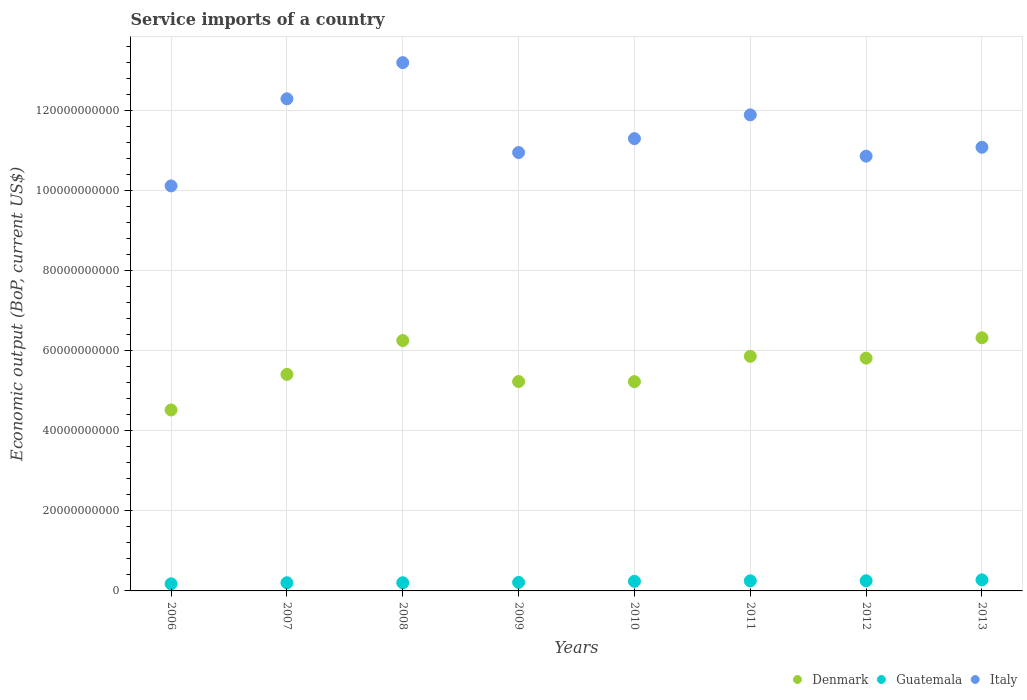How many different coloured dotlines are there?
Give a very brief answer. 3. Is the number of dotlines equal to the number of legend labels?
Make the answer very short. Yes. What is the service imports in Guatemala in 2012?
Provide a succinct answer. 2.54e+09. Across all years, what is the maximum service imports in Denmark?
Make the answer very short. 6.33e+1. Across all years, what is the minimum service imports in Guatemala?
Keep it short and to the point. 1.78e+09. In which year was the service imports in Denmark minimum?
Ensure brevity in your answer.  2006. What is the total service imports in Italy in the graph?
Your answer should be very brief. 9.17e+11. What is the difference between the service imports in Italy in 2009 and that in 2011?
Your answer should be very brief. -9.42e+09. What is the difference between the service imports in Denmark in 2007 and the service imports in Guatemala in 2009?
Ensure brevity in your answer.  5.20e+1. What is the average service imports in Guatemala per year?
Make the answer very short. 2.28e+09. In the year 2011, what is the difference between the service imports in Denmark and service imports in Guatemala?
Keep it short and to the point. 5.61e+1. What is the ratio of the service imports in Italy in 2006 to that in 2011?
Make the answer very short. 0.85. Is the service imports in Guatemala in 2007 less than that in 2013?
Your answer should be compact. Yes. What is the difference between the highest and the second highest service imports in Denmark?
Give a very brief answer. 6.86e+08. What is the difference between the highest and the lowest service imports in Guatemala?
Keep it short and to the point. 9.79e+08. In how many years, is the service imports in Italy greater than the average service imports in Italy taken over all years?
Your response must be concise. 3. Is it the case that in every year, the sum of the service imports in Guatemala and service imports in Italy  is greater than the service imports in Denmark?
Provide a short and direct response. Yes. Does the service imports in Italy monotonically increase over the years?
Give a very brief answer. No. Is the service imports in Denmark strictly greater than the service imports in Italy over the years?
Provide a short and direct response. No. Is the service imports in Denmark strictly less than the service imports in Italy over the years?
Offer a very short reply. Yes. How many years are there in the graph?
Give a very brief answer. 8. Are the values on the major ticks of Y-axis written in scientific E-notation?
Your response must be concise. No. Does the graph contain any zero values?
Your response must be concise. No. Does the graph contain grids?
Provide a succinct answer. Yes. Where does the legend appear in the graph?
Ensure brevity in your answer.  Bottom right. How are the legend labels stacked?
Offer a terse response. Horizontal. What is the title of the graph?
Your response must be concise. Service imports of a country. What is the label or title of the X-axis?
Offer a very short reply. Years. What is the label or title of the Y-axis?
Your answer should be compact. Economic output (BoP, current US$). What is the Economic output (BoP, current US$) in Denmark in 2006?
Keep it short and to the point. 4.52e+1. What is the Economic output (BoP, current US$) of Guatemala in 2006?
Ensure brevity in your answer.  1.78e+09. What is the Economic output (BoP, current US$) of Italy in 2006?
Provide a short and direct response. 1.01e+11. What is the Economic output (BoP, current US$) in Denmark in 2007?
Your response must be concise. 5.41e+1. What is the Economic output (BoP, current US$) of Guatemala in 2007?
Your response must be concise. 2.04e+09. What is the Economic output (BoP, current US$) of Italy in 2007?
Offer a terse response. 1.23e+11. What is the Economic output (BoP, current US$) of Denmark in 2008?
Give a very brief answer. 6.26e+1. What is the Economic output (BoP, current US$) in Guatemala in 2008?
Your answer should be compact. 2.04e+09. What is the Economic output (BoP, current US$) of Italy in 2008?
Your answer should be compact. 1.32e+11. What is the Economic output (BoP, current US$) in Denmark in 2009?
Your answer should be compact. 5.23e+1. What is the Economic output (BoP, current US$) in Guatemala in 2009?
Offer a terse response. 2.13e+09. What is the Economic output (BoP, current US$) in Italy in 2009?
Your response must be concise. 1.10e+11. What is the Economic output (BoP, current US$) in Denmark in 2010?
Provide a succinct answer. 5.23e+1. What is the Economic output (BoP, current US$) in Guatemala in 2010?
Your response must be concise. 2.41e+09. What is the Economic output (BoP, current US$) in Italy in 2010?
Keep it short and to the point. 1.13e+11. What is the Economic output (BoP, current US$) in Denmark in 2011?
Offer a very short reply. 5.86e+1. What is the Economic output (BoP, current US$) in Guatemala in 2011?
Offer a terse response. 2.52e+09. What is the Economic output (BoP, current US$) in Italy in 2011?
Your response must be concise. 1.19e+11. What is the Economic output (BoP, current US$) of Denmark in 2012?
Keep it short and to the point. 5.82e+1. What is the Economic output (BoP, current US$) in Guatemala in 2012?
Offer a terse response. 2.54e+09. What is the Economic output (BoP, current US$) in Italy in 2012?
Give a very brief answer. 1.09e+11. What is the Economic output (BoP, current US$) of Denmark in 2013?
Your response must be concise. 6.33e+1. What is the Economic output (BoP, current US$) in Guatemala in 2013?
Your answer should be very brief. 2.76e+09. What is the Economic output (BoP, current US$) of Italy in 2013?
Give a very brief answer. 1.11e+11. Across all years, what is the maximum Economic output (BoP, current US$) in Denmark?
Ensure brevity in your answer.  6.33e+1. Across all years, what is the maximum Economic output (BoP, current US$) of Guatemala?
Your response must be concise. 2.76e+09. Across all years, what is the maximum Economic output (BoP, current US$) in Italy?
Make the answer very short. 1.32e+11. Across all years, what is the minimum Economic output (BoP, current US$) of Denmark?
Ensure brevity in your answer.  4.52e+1. Across all years, what is the minimum Economic output (BoP, current US$) in Guatemala?
Your response must be concise. 1.78e+09. Across all years, what is the minimum Economic output (BoP, current US$) in Italy?
Give a very brief answer. 1.01e+11. What is the total Economic output (BoP, current US$) in Denmark in the graph?
Keep it short and to the point. 4.47e+11. What is the total Economic output (BoP, current US$) of Guatemala in the graph?
Offer a very short reply. 1.82e+1. What is the total Economic output (BoP, current US$) in Italy in the graph?
Your response must be concise. 9.17e+11. What is the difference between the Economic output (BoP, current US$) of Denmark in 2006 and that in 2007?
Your answer should be very brief. -8.89e+09. What is the difference between the Economic output (BoP, current US$) of Guatemala in 2006 and that in 2007?
Keep it short and to the point. -2.63e+08. What is the difference between the Economic output (BoP, current US$) of Italy in 2006 and that in 2007?
Your answer should be compact. -2.18e+1. What is the difference between the Economic output (BoP, current US$) in Denmark in 2006 and that in 2008?
Offer a terse response. -1.74e+1. What is the difference between the Economic output (BoP, current US$) of Guatemala in 2006 and that in 2008?
Keep it short and to the point. -2.65e+08. What is the difference between the Economic output (BoP, current US$) of Italy in 2006 and that in 2008?
Provide a succinct answer. -3.08e+1. What is the difference between the Economic output (BoP, current US$) of Denmark in 2006 and that in 2009?
Give a very brief answer. -7.11e+09. What is the difference between the Economic output (BoP, current US$) of Guatemala in 2006 and that in 2009?
Your response must be concise. -3.53e+08. What is the difference between the Economic output (BoP, current US$) of Italy in 2006 and that in 2009?
Your response must be concise. -8.34e+09. What is the difference between the Economic output (BoP, current US$) in Denmark in 2006 and that in 2010?
Give a very brief answer. -7.08e+09. What is the difference between the Economic output (BoP, current US$) in Guatemala in 2006 and that in 2010?
Provide a short and direct response. -6.29e+08. What is the difference between the Economic output (BoP, current US$) of Italy in 2006 and that in 2010?
Your answer should be compact. -1.18e+1. What is the difference between the Economic output (BoP, current US$) in Denmark in 2006 and that in 2011?
Provide a succinct answer. -1.34e+1. What is the difference between the Economic output (BoP, current US$) in Guatemala in 2006 and that in 2011?
Provide a short and direct response. -7.38e+08. What is the difference between the Economic output (BoP, current US$) in Italy in 2006 and that in 2011?
Your answer should be compact. -1.78e+1. What is the difference between the Economic output (BoP, current US$) of Denmark in 2006 and that in 2012?
Ensure brevity in your answer.  -1.29e+1. What is the difference between the Economic output (BoP, current US$) of Guatemala in 2006 and that in 2012?
Offer a very short reply. -7.61e+08. What is the difference between the Economic output (BoP, current US$) in Italy in 2006 and that in 2012?
Your response must be concise. -7.44e+09. What is the difference between the Economic output (BoP, current US$) of Denmark in 2006 and that in 2013?
Offer a very short reply. -1.80e+1. What is the difference between the Economic output (BoP, current US$) of Guatemala in 2006 and that in 2013?
Provide a succinct answer. -9.79e+08. What is the difference between the Economic output (BoP, current US$) in Italy in 2006 and that in 2013?
Ensure brevity in your answer.  -9.66e+09. What is the difference between the Economic output (BoP, current US$) in Denmark in 2007 and that in 2008?
Give a very brief answer. -8.46e+09. What is the difference between the Economic output (BoP, current US$) of Guatemala in 2007 and that in 2008?
Keep it short and to the point. -2.11e+06. What is the difference between the Economic output (BoP, current US$) in Italy in 2007 and that in 2008?
Your answer should be compact. -9.04e+09. What is the difference between the Economic output (BoP, current US$) in Denmark in 2007 and that in 2009?
Your response must be concise. 1.78e+09. What is the difference between the Economic output (BoP, current US$) of Guatemala in 2007 and that in 2009?
Offer a very short reply. -9.03e+07. What is the difference between the Economic output (BoP, current US$) in Italy in 2007 and that in 2009?
Provide a short and direct response. 1.34e+1. What is the difference between the Economic output (BoP, current US$) in Denmark in 2007 and that in 2010?
Your answer should be compact. 1.81e+09. What is the difference between the Economic output (BoP, current US$) in Guatemala in 2007 and that in 2010?
Offer a very short reply. -3.66e+08. What is the difference between the Economic output (BoP, current US$) in Italy in 2007 and that in 2010?
Provide a short and direct response. 9.95e+09. What is the difference between the Economic output (BoP, current US$) in Denmark in 2007 and that in 2011?
Provide a succinct answer. -4.52e+09. What is the difference between the Economic output (BoP, current US$) of Guatemala in 2007 and that in 2011?
Your response must be concise. -4.76e+08. What is the difference between the Economic output (BoP, current US$) of Italy in 2007 and that in 2011?
Give a very brief answer. 4.01e+09. What is the difference between the Economic output (BoP, current US$) in Denmark in 2007 and that in 2012?
Offer a very short reply. -4.06e+09. What is the difference between the Economic output (BoP, current US$) of Guatemala in 2007 and that in 2012?
Ensure brevity in your answer.  -4.98e+08. What is the difference between the Economic output (BoP, current US$) in Italy in 2007 and that in 2012?
Provide a succinct answer. 1.43e+1. What is the difference between the Economic output (BoP, current US$) of Denmark in 2007 and that in 2013?
Offer a terse response. -9.15e+09. What is the difference between the Economic output (BoP, current US$) in Guatemala in 2007 and that in 2013?
Provide a succinct answer. -7.16e+08. What is the difference between the Economic output (BoP, current US$) of Italy in 2007 and that in 2013?
Your answer should be very brief. 1.21e+1. What is the difference between the Economic output (BoP, current US$) in Denmark in 2008 and that in 2009?
Ensure brevity in your answer.  1.02e+1. What is the difference between the Economic output (BoP, current US$) of Guatemala in 2008 and that in 2009?
Your response must be concise. -8.82e+07. What is the difference between the Economic output (BoP, current US$) in Italy in 2008 and that in 2009?
Your answer should be compact. 2.25e+1. What is the difference between the Economic output (BoP, current US$) of Denmark in 2008 and that in 2010?
Ensure brevity in your answer.  1.03e+1. What is the difference between the Economic output (BoP, current US$) of Guatemala in 2008 and that in 2010?
Keep it short and to the point. -3.64e+08. What is the difference between the Economic output (BoP, current US$) of Italy in 2008 and that in 2010?
Your answer should be very brief. 1.90e+1. What is the difference between the Economic output (BoP, current US$) of Denmark in 2008 and that in 2011?
Ensure brevity in your answer.  3.94e+09. What is the difference between the Economic output (BoP, current US$) of Guatemala in 2008 and that in 2011?
Ensure brevity in your answer.  -4.74e+08. What is the difference between the Economic output (BoP, current US$) of Italy in 2008 and that in 2011?
Your answer should be compact. 1.31e+1. What is the difference between the Economic output (BoP, current US$) of Denmark in 2008 and that in 2012?
Provide a short and direct response. 4.40e+09. What is the difference between the Economic output (BoP, current US$) of Guatemala in 2008 and that in 2012?
Ensure brevity in your answer.  -4.96e+08. What is the difference between the Economic output (BoP, current US$) in Italy in 2008 and that in 2012?
Make the answer very short. 2.34e+1. What is the difference between the Economic output (BoP, current US$) of Denmark in 2008 and that in 2013?
Offer a very short reply. -6.86e+08. What is the difference between the Economic output (BoP, current US$) in Guatemala in 2008 and that in 2013?
Make the answer very short. -7.14e+08. What is the difference between the Economic output (BoP, current US$) in Italy in 2008 and that in 2013?
Offer a terse response. 2.12e+1. What is the difference between the Economic output (BoP, current US$) in Denmark in 2009 and that in 2010?
Offer a very short reply. 2.79e+07. What is the difference between the Economic output (BoP, current US$) of Guatemala in 2009 and that in 2010?
Give a very brief answer. -2.76e+08. What is the difference between the Economic output (BoP, current US$) in Italy in 2009 and that in 2010?
Ensure brevity in your answer.  -3.48e+09. What is the difference between the Economic output (BoP, current US$) of Denmark in 2009 and that in 2011?
Provide a short and direct response. -6.30e+09. What is the difference between the Economic output (BoP, current US$) in Guatemala in 2009 and that in 2011?
Your answer should be compact. -3.85e+08. What is the difference between the Economic output (BoP, current US$) in Italy in 2009 and that in 2011?
Provide a short and direct response. -9.42e+09. What is the difference between the Economic output (BoP, current US$) in Denmark in 2009 and that in 2012?
Your response must be concise. -5.84e+09. What is the difference between the Economic output (BoP, current US$) of Guatemala in 2009 and that in 2012?
Make the answer very short. -4.08e+08. What is the difference between the Economic output (BoP, current US$) of Italy in 2009 and that in 2012?
Give a very brief answer. 9.00e+08. What is the difference between the Economic output (BoP, current US$) of Denmark in 2009 and that in 2013?
Offer a terse response. -1.09e+1. What is the difference between the Economic output (BoP, current US$) of Guatemala in 2009 and that in 2013?
Provide a short and direct response. -6.25e+08. What is the difference between the Economic output (BoP, current US$) of Italy in 2009 and that in 2013?
Keep it short and to the point. -1.32e+09. What is the difference between the Economic output (BoP, current US$) of Denmark in 2010 and that in 2011?
Your answer should be very brief. -6.33e+09. What is the difference between the Economic output (BoP, current US$) of Guatemala in 2010 and that in 2011?
Your answer should be very brief. -1.10e+08. What is the difference between the Economic output (BoP, current US$) of Italy in 2010 and that in 2011?
Make the answer very short. -5.94e+09. What is the difference between the Economic output (BoP, current US$) in Denmark in 2010 and that in 2012?
Give a very brief answer. -5.87e+09. What is the difference between the Economic output (BoP, current US$) of Guatemala in 2010 and that in 2012?
Your response must be concise. -1.32e+08. What is the difference between the Economic output (BoP, current US$) in Italy in 2010 and that in 2012?
Keep it short and to the point. 4.38e+09. What is the difference between the Economic output (BoP, current US$) of Denmark in 2010 and that in 2013?
Offer a terse response. -1.10e+1. What is the difference between the Economic output (BoP, current US$) in Guatemala in 2010 and that in 2013?
Give a very brief answer. -3.50e+08. What is the difference between the Economic output (BoP, current US$) of Italy in 2010 and that in 2013?
Your answer should be very brief. 2.16e+09. What is the difference between the Economic output (BoP, current US$) in Denmark in 2011 and that in 2012?
Offer a terse response. 4.63e+08. What is the difference between the Economic output (BoP, current US$) of Guatemala in 2011 and that in 2012?
Your answer should be very brief. -2.26e+07. What is the difference between the Economic output (BoP, current US$) in Italy in 2011 and that in 2012?
Provide a succinct answer. 1.03e+1. What is the difference between the Economic output (BoP, current US$) of Denmark in 2011 and that in 2013?
Give a very brief answer. -4.63e+09. What is the difference between the Economic output (BoP, current US$) of Guatemala in 2011 and that in 2013?
Your answer should be very brief. -2.40e+08. What is the difference between the Economic output (BoP, current US$) in Italy in 2011 and that in 2013?
Your response must be concise. 8.10e+09. What is the difference between the Economic output (BoP, current US$) in Denmark in 2012 and that in 2013?
Your response must be concise. -5.09e+09. What is the difference between the Economic output (BoP, current US$) in Guatemala in 2012 and that in 2013?
Your response must be concise. -2.18e+08. What is the difference between the Economic output (BoP, current US$) of Italy in 2012 and that in 2013?
Ensure brevity in your answer.  -2.22e+09. What is the difference between the Economic output (BoP, current US$) of Denmark in 2006 and the Economic output (BoP, current US$) of Guatemala in 2007?
Provide a succinct answer. 4.32e+1. What is the difference between the Economic output (BoP, current US$) in Denmark in 2006 and the Economic output (BoP, current US$) in Italy in 2007?
Make the answer very short. -7.78e+1. What is the difference between the Economic output (BoP, current US$) of Guatemala in 2006 and the Economic output (BoP, current US$) of Italy in 2007?
Provide a short and direct response. -1.21e+11. What is the difference between the Economic output (BoP, current US$) of Denmark in 2006 and the Economic output (BoP, current US$) of Guatemala in 2008?
Provide a succinct answer. 4.32e+1. What is the difference between the Economic output (BoP, current US$) in Denmark in 2006 and the Economic output (BoP, current US$) in Italy in 2008?
Provide a short and direct response. -8.68e+1. What is the difference between the Economic output (BoP, current US$) in Guatemala in 2006 and the Economic output (BoP, current US$) in Italy in 2008?
Provide a short and direct response. -1.30e+11. What is the difference between the Economic output (BoP, current US$) of Denmark in 2006 and the Economic output (BoP, current US$) of Guatemala in 2009?
Provide a short and direct response. 4.31e+1. What is the difference between the Economic output (BoP, current US$) in Denmark in 2006 and the Economic output (BoP, current US$) in Italy in 2009?
Provide a succinct answer. -6.43e+1. What is the difference between the Economic output (BoP, current US$) in Guatemala in 2006 and the Economic output (BoP, current US$) in Italy in 2009?
Give a very brief answer. -1.08e+11. What is the difference between the Economic output (BoP, current US$) of Denmark in 2006 and the Economic output (BoP, current US$) of Guatemala in 2010?
Provide a succinct answer. 4.28e+1. What is the difference between the Economic output (BoP, current US$) in Denmark in 2006 and the Economic output (BoP, current US$) in Italy in 2010?
Provide a succinct answer. -6.78e+1. What is the difference between the Economic output (BoP, current US$) of Guatemala in 2006 and the Economic output (BoP, current US$) of Italy in 2010?
Your answer should be compact. -1.11e+11. What is the difference between the Economic output (BoP, current US$) in Denmark in 2006 and the Economic output (BoP, current US$) in Guatemala in 2011?
Give a very brief answer. 4.27e+1. What is the difference between the Economic output (BoP, current US$) of Denmark in 2006 and the Economic output (BoP, current US$) of Italy in 2011?
Keep it short and to the point. -7.38e+1. What is the difference between the Economic output (BoP, current US$) in Guatemala in 2006 and the Economic output (BoP, current US$) in Italy in 2011?
Your answer should be compact. -1.17e+11. What is the difference between the Economic output (BoP, current US$) of Denmark in 2006 and the Economic output (BoP, current US$) of Guatemala in 2012?
Your answer should be very brief. 4.27e+1. What is the difference between the Economic output (BoP, current US$) in Denmark in 2006 and the Economic output (BoP, current US$) in Italy in 2012?
Offer a terse response. -6.34e+1. What is the difference between the Economic output (BoP, current US$) of Guatemala in 2006 and the Economic output (BoP, current US$) of Italy in 2012?
Your answer should be compact. -1.07e+11. What is the difference between the Economic output (BoP, current US$) in Denmark in 2006 and the Economic output (BoP, current US$) in Guatemala in 2013?
Keep it short and to the point. 4.25e+1. What is the difference between the Economic output (BoP, current US$) of Denmark in 2006 and the Economic output (BoP, current US$) of Italy in 2013?
Your answer should be compact. -6.57e+1. What is the difference between the Economic output (BoP, current US$) of Guatemala in 2006 and the Economic output (BoP, current US$) of Italy in 2013?
Your response must be concise. -1.09e+11. What is the difference between the Economic output (BoP, current US$) of Denmark in 2007 and the Economic output (BoP, current US$) of Guatemala in 2008?
Give a very brief answer. 5.21e+1. What is the difference between the Economic output (BoP, current US$) in Denmark in 2007 and the Economic output (BoP, current US$) in Italy in 2008?
Offer a terse response. -7.79e+1. What is the difference between the Economic output (BoP, current US$) of Guatemala in 2007 and the Economic output (BoP, current US$) of Italy in 2008?
Ensure brevity in your answer.  -1.30e+11. What is the difference between the Economic output (BoP, current US$) of Denmark in 2007 and the Economic output (BoP, current US$) of Guatemala in 2009?
Your response must be concise. 5.20e+1. What is the difference between the Economic output (BoP, current US$) of Denmark in 2007 and the Economic output (BoP, current US$) of Italy in 2009?
Keep it short and to the point. -5.55e+1. What is the difference between the Economic output (BoP, current US$) of Guatemala in 2007 and the Economic output (BoP, current US$) of Italy in 2009?
Make the answer very short. -1.08e+11. What is the difference between the Economic output (BoP, current US$) of Denmark in 2007 and the Economic output (BoP, current US$) of Guatemala in 2010?
Ensure brevity in your answer.  5.17e+1. What is the difference between the Economic output (BoP, current US$) of Denmark in 2007 and the Economic output (BoP, current US$) of Italy in 2010?
Ensure brevity in your answer.  -5.89e+1. What is the difference between the Economic output (BoP, current US$) of Guatemala in 2007 and the Economic output (BoP, current US$) of Italy in 2010?
Your answer should be very brief. -1.11e+11. What is the difference between the Economic output (BoP, current US$) of Denmark in 2007 and the Economic output (BoP, current US$) of Guatemala in 2011?
Keep it short and to the point. 5.16e+1. What is the difference between the Economic output (BoP, current US$) in Denmark in 2007 and the Economic output (BoP, current US$) in Italy in 2011?
Keep it short and to the point. -6.49e+1. What is the difference between the Economic output (BoP, current US$) of Guatemala in 2007 and the Economic output (BoP, current US$) of Italy in 2011?
Ensure brevity in your answer.  -1.17e+11. What is the difference between the Economic output (BoP, current US$) in Denmark in 2007 and the Economic output (BoP, current US$) in Guatemala in 2012?
Offer a very short reply. 5.16e+1. What is the difference between the Economic output (BoP, current US$) of Denmark in 2007 and the Economic output (BoP, current US$) of Italy in 2012?
Make the answer very short. -5.46e+1. What is the difference between the Economic output (BoP, current US$) of Guatemala in 2007 and the Economic output (BoP, current US$) of Italy in 2012?
Keep it short and to the point. -1.07e+11. What is the difference between the Economic output (BoP, current US$) in Denmark in 2007 and the Economic output (BoP, current US$) in Guatemala in 2013?
Make the answer very short. 5.14e+1. What is the difference between the Economic output (BoP, current US$) in Denmark in 2007 and the Economic output (BoP, current US$) in Italy in 2013?
Offer a terse response. -5.68e+1. What is the difference between the Economic output (BoP, current US$) in Guatemala in 2007 and the Economic output (BoP, current US$) in Italy in 2013?
Provide a short and direct response. -1.09e+11. What is the difference between the Economic output (BoP, current US$) in Denmark in 2008 and the Economic output (BoP, current US$) in Guatemala in 2009?
Your answer should be very brief. 6.05e+1. What is the difference between the Economic output (BoP, current US$) in Denmark in 2008 and the Economic output (BoP, current US$) in Italy in 2009?
Give a very brief answer. -4.70e+1. What is the difference between the Economic output (BoP, current US$) in Guatemala in 2008 and the Economic output (BoP, current US$) in Italy in 2009?
Keep it short and to the point. -1.08e+11. What is the difference between the Economic output (BoP, current US$) in Denmark in 2008 and the Economic output (BoP, current US$) in Guatemala in 2010?
Ensure brevity in your answer.  6.02e+1. What is the difference between the Economic output (BoP, current US$) in Denmark in 2008 and the Economic output (BoP, current US$) in Italy in 2010?
Your response must be concise. -5.05e+1. What is the difference between the Economic output (BoP, current US$) in Guatemala in 2008 and the Economic output (BoP, current US$) in Italy in 2010?
Offer a terse response. -1.11e+11. What is the difference between the Economic output (BoP, current US$) in Denmark in 2008 and the Economic output (BoP, current US$) in Guatemala in 2011?
Give a very brief answer. 6.01e+1. What is the difference between the Economic output (BoP, current US$) in Denmark in 2008 and the Economic output (BoP, current US$) in Italy in 2011?
Provide a succinct answer. -5.64e+1. What is the difference between the Economic output (BoP, current US$) in Guatemala in 2008 and the Economic output (BoP, current US$) in Italy in 2011?
Give a very brief answer. -1.17e+11. What is the difference between the Economic output (BoP, current US$) of Denmark in 2008 and the Economic output (BoP, current US$) of Guatemala in 2012?
Keep it short and to the point. 6.00e+1. What is the difference between the Economic output (BoP, current US$) in Denmark in 2008 and the Economic output (BoP, current US$) in Italy in 2012?
Your answer should be compact. -4.61e+1. What is the difference between the Economic output (BoP, current US$) in Guatemala in 2008 and the Economic output (BoP, current US$) in Italy in 2012?
Offer a terse response. -1.07e+11. What is the difference between the Economic output (BoP, current US$) of Denmark in 2008 and the Economic output (BoP, current US$) of Guatemala in 2013?
Your response must be concise. 5.98e+1. What is the difference between the Economic output (BoP, current US$) in Denmark in 2008 and the Economic output (BoP, current US$) in Italy in 2013?
Give a very brief answer. -4.83e+1. What is the difference between the Economic output (BoP, current US$) of Guatemala in 2008 and the Economic output (BoP, current US$) of Italy in 2013?
Provide a succinct answer. -1.09e+11. What is the difference between the Economic output (BoP, current US$) in Denmark in 2009 and the Economic output (BoP, current US$) in Guatemala in 2010?
Offer a very short reply. 4.99e+1. What is the difference between the Economic output (BoP, current US$) of Denmark in 2009 and the Economic output (BoP, current US$) of Italy in 2010?
Provide a short and direct response. -6.07e+1. What is the difference between the Economic output (BoP, current US$) in Guatemala in 2009 and the Economic output (BoP, current US$) in Italy in 2010?
Offer a terse response. -1.11e+11. What is the difference between the Economic output (BoP, current US$) of Denmark in 2009 and the Economic output (BoP, current US$) of Guatemala in 2011?
Give a very brief answer. 4.98e+1. What is the difference between the Economic output (BoP, current US$) in Denmark in 2009 and the Economic output (BoP, current US$) in Italy in 2011?
Provide a succinct answer. -6.67e+1. What is the difference between the Economic output (BoP, current US$) in Guatemala in 2009 and the Economic output (BoP, current US$) in Italy in 2011?
Your response must be concise. -1.17e+11. What is the difference between the Economic output (BoP, current US$) in Denmark in 2009 and the Economic output (BoP, current US$) in Guatemala in 2012?
Provide a short and direct response. 4.98e+1. What is the difference between the Economic output (BoP, current US$) in Denmark in 2009 and the Economic output (BoP, current US$) in Italy in 2012?
Ensure brevity in your answer.  -5.63e+1. What is the difference between the Economic output (BoP, current US$) in Guatemala in 2009 and the Economic output (BoP, current US$) in Italy in 2012?
Your response must be concise. -1.07e+11. What is the difference between the Economic output (BoP, current US$) of Denmark in 2009 and the Economic output (BoP, current US$) of Guatemala in 2013?
Keep it short and to the point. 4.96e+1. What is the difference between the Economic output (BoP, current US$) in Denmark in 2009 and the Economic output (BoP, current US$) in Italy in 2013?
Ensure brevity in your answer.  -5.86e+1. What is the difference between the Economic output (BoP, current US$) in Guatemala in 2009 and the Economic output (BoP, current US$) in Italy in 2013?
Offer a terse response. -1.09e+11. What is the difference between the Economic output (BoP, current US$) in Denmark in 2010 and the Economic output (BoP, current US$) in Guatemala in 2011?
Make the answer very short. 4.98e+1. What is the difference between the Economic output (BoP, current US$) of Denmark in 2010 and the Economic output (BoP, current US$) of Italy in 2011?
Provide a short and direct response. -6.67e+1. What is the difference between the Economic output (BoP, current US$) of Guatemala in 2010 and the Economic output (BoP, current US$) of Italy in 2011?
Your answer should be very brief. -1.17e+11. What is the difference between the Economic output (BoP, current US$) of Denmark in 2010 and the Economic output (BoP, current US$) of Guatemala in 2012?
Make the answer very short. 4.98e+1. What is the difference between the Economic output (BoP, current US$) in Denmark in 2010 and the Economic output (BoP, current US$) in Italy in 2012?
Offer a terse response. -5.64e+1. What is the difference between the Economic output (BoP, current US$) of Guatemala in 2010 and the Economic output (BoP, current US$) of Italy in 2012?
Keep it short and to the point. -1.06e+11. What is the difference between the Economic output (BoP, current US$) of Denmark in 2010 and the Economic output (BoP, current US$) of Guatemala in 2013?
Ensure brevity in your answer.  4.96e+1. What is the difference between the Economic output (BoP, current US$) in Denmark in 2010 and the Economic output (BoP, current US$) in Italy in 2013?
Give a very brief answer. -5.86e+1. What is the difference between the Economic output (BoP, current US$) of Guatemala in 2010 and the Economic output (BoP, current US$) of Italy in 2013?
Offer a terse response. -1.08e+11. What is the difference between the Economic output (BoP, current US$) in Denmark in 2011 and the Economic output (BoP, current US$) in Guatemala in 2012?
Your answer should be very brief. 5.61e+1. What is the difference between the Economic output (BoP, current US$) in Denmark in 2011 and the Economic output (BoP, current US$) in Italy in 2012?
Provide a short and direct response. -5.00e+1. What is the difference between the Economic output (BoP, current US$) of Guatemala in 2011 and the Economic output (BoP, current US$) of Italy in 2012?
Provide a short and direct response. -1.06e+11. What is the difference between the Economic output (BoP, current US$) of Denmark in 2011 and the Economic output (BoP, current US$) of Guatemala in 2013?
Your answer should be very brief. 5.59e+1. What is the difference between the Economic output (BoP, current US$) in Denmark in 2011 and the Economic output (BoP, current US$) in Italy in 2013?
Give a very brief answer. -5.22e+1. What is the difference between the Economic output (BoP, current US$) in Guatemala in 2011 and the Economic output (BoP, current US$) in Italy in 2013?
Your response must be concise. -1.08e+11. What is the difference between the Economic output (BoP, current US$) of Denmark in 2012 and the Economic output (BoP, current US$) of Guatemala in 2013?
Offer a very short reply. 5.54e+1. What is the difference between the Economic output (BoP, current US$) of Denmark in 2012 and the Economic output (BoP, current US$) of Italy in 2013?
Provide a succinct answer. -5.27e+1. What is the difference between the Economic output (BoP, current US$) of Guatemala in 2012 and the Economic output (BoP, current US$) of Italy in 2013?
Provide a short and direct response. -1.08e+11. What is the average Economic output (BoP, current US$) of Denmark per year?
Make the answer very short. 5.58e+1. What is the average Economic output (BoP, current US$) in Guatemala per year?
Offer a terse response. 2.28e+09. What is the average Economic output (BoP, current US$) of Italy per year?
Provide a succinct answer. 1.15e+11. In the year 2006, what is the difference between the Economic output (BoP, current US$) in Denmark and Economic output (BoP, current US$) in Guatemala?
Your answer should be compact. 4.35e+1. In the year 2006, what is the difference between the Economic output (BoP, current US$) of Denmark and Economic output (BoP, current US$) of Italy?
Make the answer very short. -5.60e+1. In the year 2006, what is the difference between the Economic output (BoP, current US$) in Guatemala and Economic output (BoP, current US$) in Italy?
Offer a terse response. -9.95e+1. In the year 2007, what is the difference between the Economic output (BoP, current US$) in Denmark and Economic output (BoP, current US$) in Guatemala?
Provide a succinct answer. 5.21e+1. In the year 2007, what is the difference between the Economic output (BoP, current US$) of Denmark and Economic output (BoP, current US$) of Italy?
Keep it short and to the point. -6.89e+1. In the year 2007, what is the difference between the Economic output (BoP, current US$) of Guatemala and Economic output (BoP, current US$) of Italy?
Offer a very short reply. -1.21e+11. In the year 2008, what is the difference between the Economic output (BoP, current US$) of Denmark and Economic output (BoP, current US$) of Guatemala?
Give a very brief answer. 6.05e+1. In the year 2008, what is the difference between the Economic output (BoP, current US$) in Denmark and Economic output (BoP, current US$) in Italy?
Your answer should be compact. -6.95e+1. In the year 2008, what is the difference between the Economic output (BoP, current US$) of Guatemala and Economic output (BoP, current US$) of Italy?
Provide a succinct answer. -1.30e+11. In the year 2009, what is the difference between the Economic output (BoP, current US$) of Denmark and Economic output (BoP, current US$) of Guatemala?
Make the answer very short. 5.02e+1. In the year 2009, what is the difference between the Economic output (BoP, current US$) of Denmark and Economic output (BoP, current US$) of Italy?
Provide a succinct answer. -5.72e+1. In the year 2009, what is the difference between the Economic output (BoP, current US$) of Guatemala and Economic output (BoP, current US$) of Italy?
Your answer should be very brief. -1.07e+11. In the year 2010, what is the difference between the Economic output (BoP, current US$) of Denmark and Economic output (BoP, current US$) of Guatemala?
Provide a succinct answer. 4.99e+1. In the year 2010, what is the difference between the Economic output (BoP, current US$) in Denmark and Economic output (BoP, current US$) in Italy?
Offer a very short reply. -6.07e+1. In the year 2010, what is the difference between the Economic output (BoP, current US$) in Guatemala and Economic output (BoP, current US$) in Italy?
Offer a very short reply. -1.11e+11. In the year 2011, what is the difference between the Economic output (BoP, current US$) in Denmark and Economic output (BoP, current US$) in Guatemala?
Keep it short and to the point. 5.61e+1. In the year 2011, what is the difference between the Economic output (BoP, current US$) in Denmark and Economic output (BoP, current US$) in Italy?
Make the answer very short. -6.04e+1. In the year 2011, what is the difference between the Economic output (BoP, current US$) in Guatemala and Economic output (BoP, current US$) in Italy?
Keep it short and to the point. -1.16e+11. In the year 2012, what is the difference between the Economic output (BoP, current US$) in Denmark and Economic output (BoP, current US$) in Guatemala?
Provide a succinct answer. 5.56e+1. In the year 2012, what is the difference between the Economic output (BoP, current US$) of Denmark and Economic output (BoP, current US$) of Italy?
Keep it short and to the point. -5.05e+1. In the year 2012, what is the difference between the Economic output (BoP, current US$) of Guatemala and Economic output (BoP, current US$) of Italy?
Your answer should be very brief. -1.06e+11. In the year 2013, what is the difference between the Economic output (BoP, current US$) of Denmark and Economic output (BoP, current US$) of Guatemala?
Your answer should be very brief. 6.05e+1. In the year 2013, what is the difference between the Economic output (BoP, current US$) of Denmark and Economic output (BoP, current US$) of Italy?
Your answer should be compact. -4.76e+1. In the year 2013, what is the difference between the Economic output (BoP, current US$) in Guatemala and Economic output (BoP, current US$) in Italy?
Keep it short and to the point. -1.08e+11. What is the ratio of the Economic output (BoP, current US$) of Denmark in 2006 to that in 2007?
Your response must be concise. 0.84. What is the ratio of the Economic output (BoP, current US$) of Guatemala in 2006 to that in 2007?
Make the answer very short. 0.87. What is the ratio of the Economic output (BoP, current US$) of Italy in 2006 to that in 2007?
Your answer should be compact. 0.82. What is the ratio of the Economic output (BoP, current US$) of Denmark in 2006 to that in 2008?
Offer a terse response. 0.72. What is the ratio of the Economic output (BoP, current US$) in Guatemala in 2006 to that in 2008?
Give a very brief answer. 0.87. What is the ratio of the Economic output (BoP, current US$) of Italy in 2006 to that in 2008?
Make the answer very short. 0.77. What is the ratio of the Economic output (BoP, current US$) in Denmark in 2006 to that in 2009?
Make the answer very short. 0.86. What is the ratio of the Economic output (BoP, current US$) of Guatemala in 2006 to that in 2009?
Provide a short and direct response. 0.83. What is the ratio of the Economic output (BoP, current US$) in Italy in 2006 to that in 2009?
Your answer should be very brief. 0.92. What is the ratio of the Economic output (BoP, current US$) of Denmark in 2006 to that in 2010?
Provide a short and direct response. 0.86. What is the ratio of the Economic output (BoP, current US$) in Guatemala in 2006 to that in 2010?
Your answer should be compact. 0.74. What is the ratio of the Economic output (BoP, current US$) of Italy in 2006 to that in 2010?
Keep it short and to the point. 0.9. What is the ratio of the Economic output (BoP, current US$) of Denmark in 2006 to that in 2011?
Ensure brevity in your answer.  0.77. What is the ratio of the Economic output (BoP, current US$) of Guatemala in 2006 to that in 2011?
Ensure brevity in your answer.  0.71. What is the ratio of the Economic output (BoP, current US$) in Italy in 2006 to that in 2011?
Provide a succinct answer. 0.85. What is the ratio of the Economic output (BoP, current US$) in Denmark in 2006 to that in 2012?
Your answer should be very brief. 0.78. What is the ratio of the Economic output (BoP, current US$) in Guatemala in 2006 to that in 2012?
Provide a short and direct response. 0.7. What is the ratio of the Economic output (BoP, current US$) in Italy in 2006 to that in 2012?
Make the answer very short. 0.93. What is the ratio of the Economic output (BoP, current US$) in Denmark in 2006 to that in 2013?
Your answer should be very brief. 0.71. What is the ratio of the Economic output (BoP, current US$) in Guatemala in 2006 to that in 2013?
Make the answer very short. 0.65. What is the ratio of the Economic output (BoP, current US$) of Italy in 2006 to that in 2013?
Your answer should be compact. 0.91. What is the ratio of the Economic output (BoP, current US$) in Denmark in 2007 to that in 2008?
Give a very brief answer. 0.86. What is the ratio of the Economic output (BoP, current US$) in Italy in 2007 to that in 2008?
Offer a terse response. 0.93. What is the ratio of the Economic output (BoP, current US$) in Denmark in 2007 to that in 2009?
Provide a short and direct response. 1.03. What is the ratio of the Economic output (BoP, current US$) of Guatemala in 2007 to that in 2009?
Ensure brevity in your answer.  0.96. What is the ratio of the Economic output (BoP, current US$) of Italy in 2007 to that in 2009?
Offer a very short reply. 1.12. What is the ratio of the Economic output (BoP, current US$) in Denmark in 2007 to that in 2010?
Offer a terse response. 1.03. What is the ratio of the Economic output (BoP, current US$) of Guatemala in 2007 to that in 2010?
Provide a short and direct response. 0.85. What is the ratio of the Economic output (BoP, current US$) of Italy in 2007 to that in 2010?
Make the answer very short. 1.09. What is the ratio of the Economic output (BoP, current US$) in Denmark in 2007 to that in 2011?
Ensure brevity in your answer.  0.92. What is the ratio of the Economic output (BoP, current US$) of Guatemala in 2007 to that in 2011?
Keep it short and to the point. 0.81. What is the ratio of the Economic output (BoP, current US$) in Italy in 2007 to that in 2011?
Keep it short and to the point. 1.03. What is the ratio of the Economic output (BoP, current US$) in Denmark in 2007 to that in 2012?
Provide a succinct answer. 0.93. What is the ratio of the Economic output (BoP, current US$) of Guatemala in 2007 to that in 2012?
Offer a very short reply. 0.8. What is the ratio of the Economic output (BoP, current US$) in Italy in 2007 to that in 2012?
Provide a short and direct response. 1.13. What is the ratio of the Economic output (BoP, current US$) in Denmark in 2007 to that in 2013?
Offer a very short reply. 0.86. What is the ratio of the Economic output (BoP, current US$) in Guatemala in 2007 to that in 2013?
Give a very brief answer. 0.74. What is the ratio of the Economic output (BoP, current US$) in Italy in 2007 to that in 2013?
Provide a succinct answer. 1.11. What is the ratio of the Economic output (BoP, current US$) of Denmark in 2008 to that in 2009?
Ensure brevity in your answer.  1.2. What is the ratio of the Economic output (BoP, current US$) of Guatemala in 2008 to that in 2009?
Provide a short and direct response. 0.96. What is the ratio of the Economic output (BoP, current US$) of Italy in 2008 to that in 2009?
Your response must be concise. 1.21. What is the ratio of the Economic output (BoP, current US$) of Denmark in 2008 to that in 2010?
Your response must be concise. 1.2. What is the ratio of the Economic output (BoP, current US$) of Guatemala in 2008 to that in 2010?
Make the answer very short. 0.85. What is the ratio of the Economic output (BoP, current US$) in Italy in 2008 to that in 2010?
Provide a short and direct response. 1.17. What is the ratio of the Economic output (BoP, current US$) of Denmark in 2008 to that in 2011?
Provide a short and direct response. 1.07. What is the ratio of the Economic output (BoP, current US$) of Guatemala in 2008 to that in 2011?
Provide a succinct answer. 0.81. What is the ratio of the Economic output (BoP, current US$) in Italy in 2008 to that in 2011?
Provide a succinct answer. 1.11. What is the ratio of the Economic output (BoP, current US$) in Denmark in 2008 to that in 2012?
Offer a terse response. 1.08. What is the ratio of the Economic output (BoP, current US$) of Guatemala in 2008 to that in 2012?
Keep it short and to the point. 0.8. What is the ratio of the Economic output (BoP, current US$) in Italy in 2008 to that in 2012?
Your answer should be very brief. 1.22. What is the ratio of the Economic output (BoP, current US$) in Denmark in 2008 to that in 2013?
Ensure brevity in your answer.  0.99. What is the ratio of the Economic output (BoP, current US$) in Guatemala in 2008 to that in 2013?
Ensure brevity in your answer.  0.74. What is the ratio of the Economic output (BoP, current US$) of Italy in 2008 to that in 2013?
Offer a very short reply. 1.19. What is the ratio of the Economic output (BoP, current US$) of Guatemala in 2009 to that in 2010?
Keep it short and to the point. 0.89. What is the ratio of the Economic output (BoP, current US$) in Italy in 2009 to that in 2010?
Offer a very short reply. 0.97. What is the ratio of the Economic output (BoP, current US$) in Denmark in 2009 to that in 2011?
Ensure brevity in your answer.  0.89. What is the ratio of the Economic output (BoP, current US$) of Guatemala in 2009 to that in 2011?
Provide a short and direct response. 0.85. What is the ratio of the Economic output (BoP, current US$) of Italy in 2009 to that in 2011?
Offer a terse response. 0.92. What is the ratio of the Economic output (BoP, current US$) in Denmark in 2009 to that in 2012?
Offer a terse response. 0.9. What is the ratio of the Economic output (BoP, current US$) in Guatemala in 2009 to that in 2012?
Provide a short and direct response. 0.84. What is the ratio of the Economic output (BoP, current US$) of Italy in 2009 to that in 2012?
Provide a succinct answer. 1.01. What is the ratio of the Economic output (BoP, current US$) in Denmark in 2009 to that in 2013?
Offer a terse response. 0.83. What is the ratio of the Economic output (BoP, current US$) of Guatemala in 2009 to that in 2013?
Your answer should be very brief. 0.77. What is the ratio of the Economic output (BoP, current US$) of Italy in 2009 to that in 2013?
Give a very brief answer. 0.99. What is the ratio of the Economic output (BoP, current US$) in Denmark in 2010 to that in 2011?
Provide a succinct answer. 0.89. What is the ratio of the Economic output (BoP, current US$) of Guatemala in 2010 to that in 2011?
Your response must be concise. 0.96. What is the ratio of the Economic output (BoP, current US$) in Italy in 2010 to that in 2011?
Provide a succinct answer. 0.95. What is the ratio of the Economic output (BoP, current US$) of Denmark in 2010 to that in 2012?
Your answer should be compact. 0.9. What is the ratio of the Economic output (BoP, current US$) of Guatemala in 2010 to that in 2012?
Give a very brief answer. 0.95. What is the ratio of the Economic output (BoP, current US$) in Italy in 2010 to that in 2012?
Make the answer very short. 1.04. What is the ratio of the Economic output (BoP, current US$) in Denmark in 2010 to that in 2013?
Your response must be concise. 0.83. What is the ratio of the Economic output (BoP, current US$) of Guatemala in 2010 to that in 2013?
Your answer should be very brief. 0.87. What is the ratio of the Economic output (BoP, current US$) of Italy in 2010 to that in 2013?
Your response must be concise. 1.02. What is the ratio of the Economic output (BoP, current US$) in Denmark in 2011 to that in 2012?
Your answer should be compact. 1.01. What is the ratio of the Economic output (BoP, current US$) in Italy in 2011 to that in 2012?
Provide a succinct answer. 1.09. What is the ratio of the Economic output (BoP, current US$) of Denmark in 2011 to that in 2013?
Give a very brief answer. 0.93. What is the ratio of the Economic output (BoP, current US$) of Guatemala in 2011 to that in 2013?
Keep it short and to the point. 0.91. What is the ratio of the Economic output (BoP, current US$) of Italy in 2011 to that in 2013?
Make the answer very short. 1.07. What is the ratio of the Economic output (BoP, current US$) in Denmark in 2012 to that in 2013?
Your response must be concise. 0.92. What is the ratio of the Economic output (BoP, current US$) of Guatemala in 2012 to that in 2013?
Ensure brevity in your answer.  0.92. What is the ratio of the Economic output (BoP, current US$) of Italy in 2012 to that in 2013?
Keep it short and to the point. 0.98. What is the difference between the highest and the second highest Economic output (BoP, current US$) in Denmark?
Your response must be concise. 6.86e+08. What is the difference between the highest and the second highest Economic output (BoP, current US$) of Guatemala?
Offer a terse response. 2.18e+08. What is the difference between the highest and the second highest Economic output (BoP, current US$) in Italy?
Your response must be concise. 9.04e+09. What is the difference between the highest and the lowest Economic output (BoP, current US$) in Denmark?
Provide a short and direct response. 1.80e+1. What is the difference between the highest and the lowest Economic output (BoP, current US$) of Guatemala?
Your answer should be compact. 9.79e+08. What is the difference between the highest and the lowest Economic output (BoP, current US$) of Italy?
Offer a very short reply. 3.08e+1. 